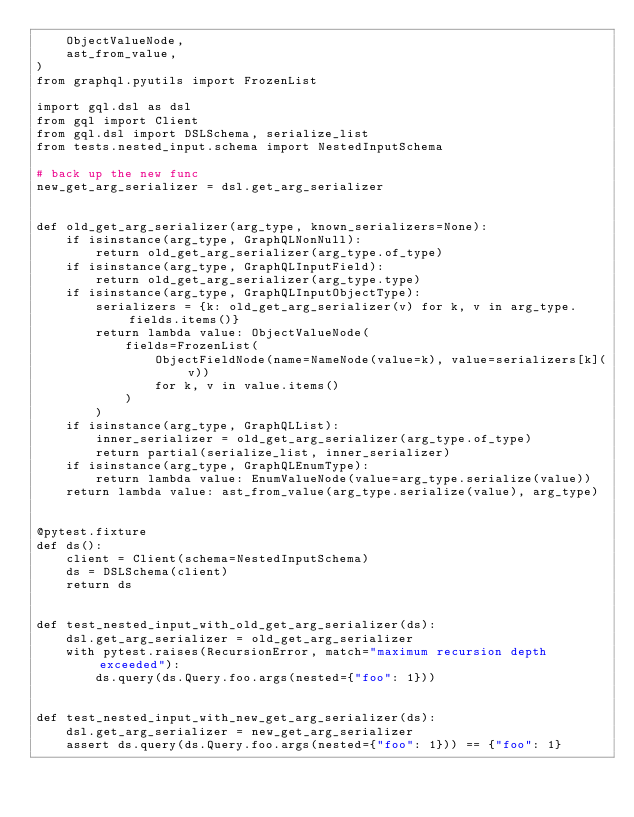<code> <loc_0><loc_0><loc_500><loc_500><_Python_>    ObjectValueNode,
    ast_from_value,
)
from graphql.pyutils import FrozenList

import gql.dsl as dsl
from gql import Client
from gql.dsl import DSLSchema, serialize_list
from tests.nested_input.schema import NestedInputSchema

# back up the new func
new_get_arg_serializer = dsl.get_arg_serializer


def old_get_arg_serializer(arg_type, known_serializers=None):
    if isinstance(arg_type, GraphQLNonNull):
        return old_get_arg_serializer(arg_type.of_type)
    if isinstance(arg_type, GraphQLInputField):
        return old_get_arg_serializer(arg_type.type)
    if isinstance(arg_type, GraphQLInputObjectType):
        serializers = {k: old_get_arg_serializer(v) for k, v in arg_type.fields.items()}
        return lambda value: ObjectValueNode(
            fields=FrozenList(
                ObjectFieldNode(name=NameNode(value=k), value=serializers[k](v))
                for k, v in value.items()
            )
        )
    if isinstance(arg_type, GraphQLList):
        inner_serializer = old_get_arg_serializer(arg_type.of_type)
        return partial(serialize_list, inner_serializer)
    if isinstance(arg_type, GraphQLEnumType):
        return lambda value: EnumValueNode(value=arg_type.serialize(value))
    return lambda value: ast_from_value(arg_type.serialize(value), arg_type)


@pytest.fixture
def ds():
    client = Client(schema=NestedInputSchema)
    ds = DSLSchema(client)
    return ds


def test_nested_input_with_old_get_arg_serializer(ds):
    dsl.get_arg_serializer = old_get_arg_serializer
    with pytest.raises(RecursionError, match="maximum recursion depth exceeded"):
        ds.query(ds.Query.foo.args(nested={"foo": 1}))


def test_nested_input_with_new_get_arg_serializer(ds):
    dsl.get_arg_serializer = new_get_arg_serializer
    assert ds.query(ds.Query.foo.args(nested={"foo": 1})) == {"foo": 1}
</code> 